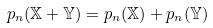<formula> <loc_0><loc_0><loc_500><loc_500>p _ { n } ( \mathbb { X } + \mathbb { Y } ) = p _ { n } ( \mathbb { X } ) + p _ { n } ( \mathbb { Y } )</formula> 